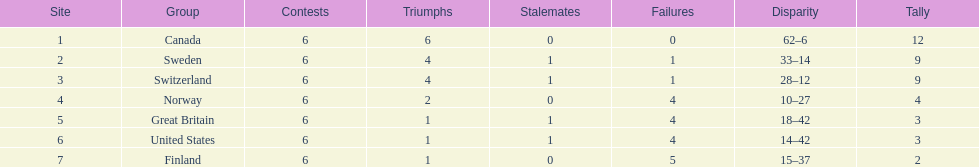How many teams won only 1 match? 3. 